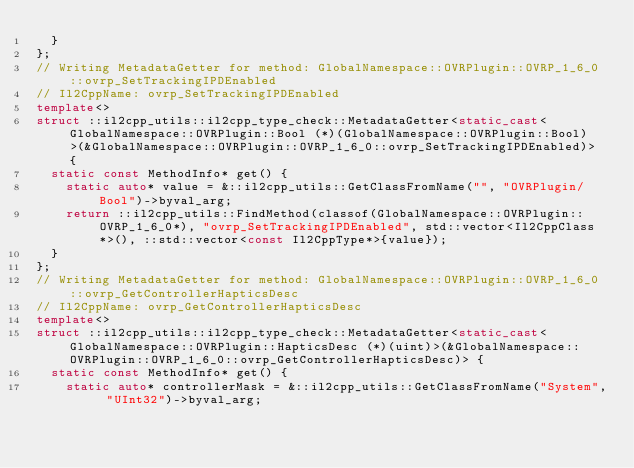<code> <loc_0><loc_0><loc_500><loc_500><_C++_>  }
};
// Writing MetadataGetter for method: GlobalNamespace::OVRPlugin::OVRP_1_6_0::ovrp_SetTrackingIPDEnabled
// Il2CppName: ovrp_SetTrackingIPDEnabled
template<>
struct ::il2cpp_utils::il2cpp_type_check::MetadataGetter<static_cast<GlobalNamespace::OVRPlugin::Bool (*)(GlobalNamespace::OVRPlugin::Bool)>(&GlobalNamespace::OVRPlugin::OVRP_1_6_0::ovrp_SetTrackingIPDEnabled)> {
  static const MethodInfo* get() {
    static auto* value = &::il2cpp_utils::GetClassFromName("", "OVRPlugin/Bool")->byval_arg;
    return ::il2cpp_utils::FindMethod(classof(GlobalNamespace::OVRPlugin::OVRP_1_6_0*), "ovrp_SetTrackingIPDEnabled", std::vector<Il2CppClass*>(), ::std::vector<const Il2CppType*>{value});
  }
};
// Writing MetadataGetter for method: GlobalNamespace::OVRPlugin::OVRP_1_6_0::ovrp_GetControllerHapticsDesc
// Il2CppName: ovrp_GetControllerHapticsDesc
template<>
struct ::il2cpp_utils::il2cpp_type_check::MetadataGetter<static_cast<GlobalNamespace::OVRPlugin::HapticsDesc (*)(uint)>(&GlobalNamespace::OVRPlugin::OVRP_1_6_0::ovrp_GetControllerHapticsDesc)> {
  static const MethodInfo* get() {
    static auto* controllerMask = &::il2cpp_utils::GetClassFromName("System", "UInt32")->byval_arg;</code> 